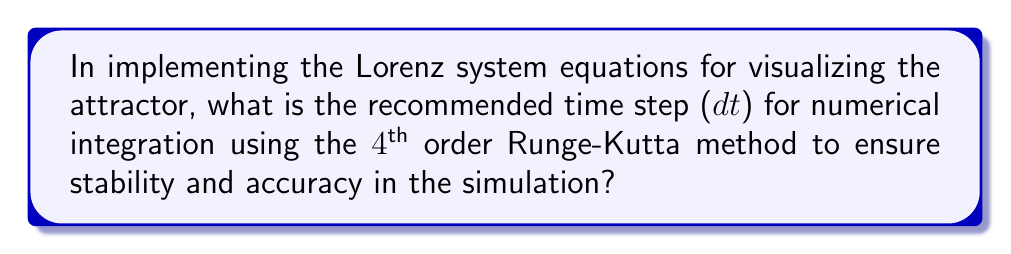Help me with this question. To determine the appropriate time step for implementing the Lorenz system equations, we need to consider the following steps:

1. Recall the Lorenz system equations:
   $$\frac{dx}{dt} = \sigma(y - x)$$
   $$\frac{dy}{dt} = x(\rho - z) - y$$
   $$\frac{dz}{dt} = xy - \beta z$$

   Where $\sigma$, $\rho$, and $\beta$ are parameters, typically set to $\sigma = 10$, $\rho = 28$, and $\beta = 8/3$.

2. The 4th order Runge-Kutta method is a popular choice for numerical integration due to its accuracy and stability. The method's local truncation error is $O(h^5)$, where $h$ is the step size.

3. For chaotic systems like the Lorenz attractor, we need to balance accuracy with computational efficiency. A smaller time step increases accuracy but requires more computational resources.

4. The characteristic time scale of the Lorenz system can be estimated using the reciprocal of the largest Lyapunov exponent, which is approximately 1.104 for the standard parameter values.

5. As a rule of thumb, we should choose a time step that is at least an order of magnitude smaller than the characteristic time scale to capture the system's dynamics accurately.

6. Considering these factors, a commonly recommended time step for the Lorenz system is dt = 0.01. This value provides a good balance between accuracy and computational efficiency for most implementations.

7. For a Linux-based implementation in a programming language like C++ or Python, this time step can be easily set as a constant or parameter in the simulation code.

8. To verify the stability and accuracy of the chosen time step, it's advisable to run the simulation with different step sizes (e.g., dt = 0.005, 0.01, 0.02) and compare the results to ensure consistency in the attractor's shape and properties.
Answer: dt = 0.01 